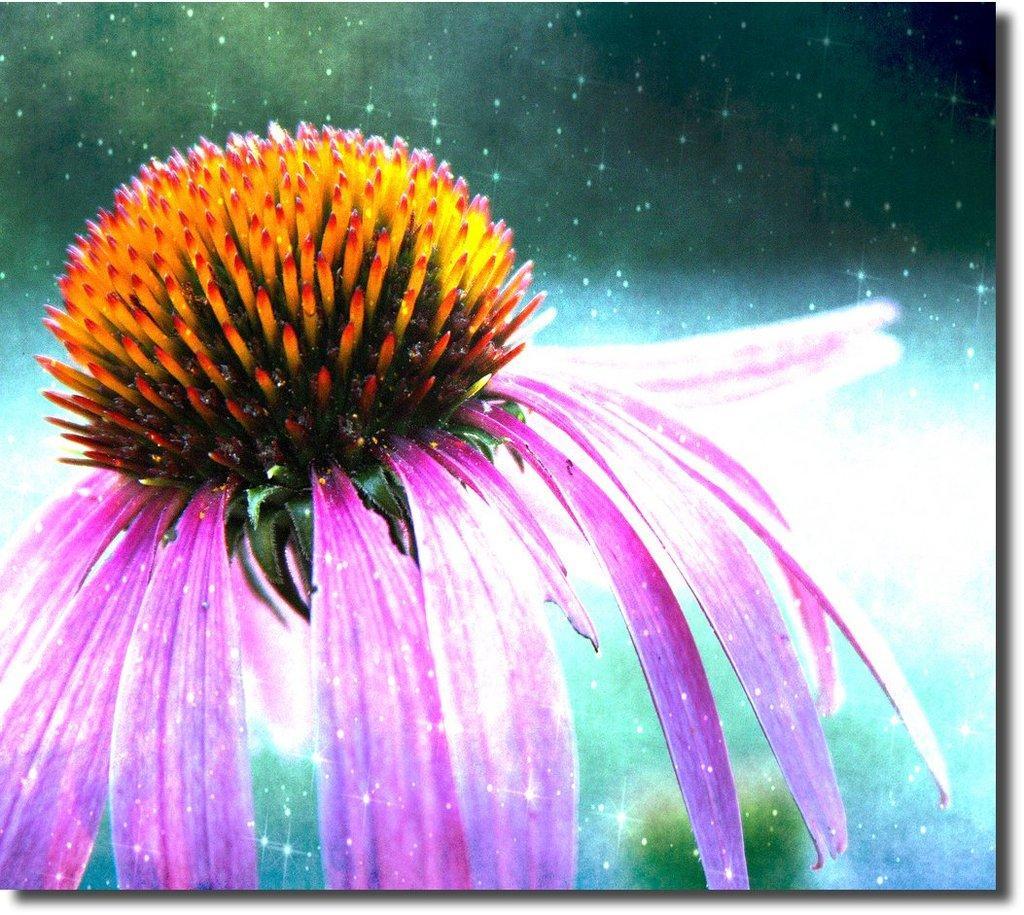Describe this image in one or two sentences. This is an edited image. In this image, on the left side, we can see a flower which is in yellow and pink color. In the background, we can see some stars, black color and blue color. 